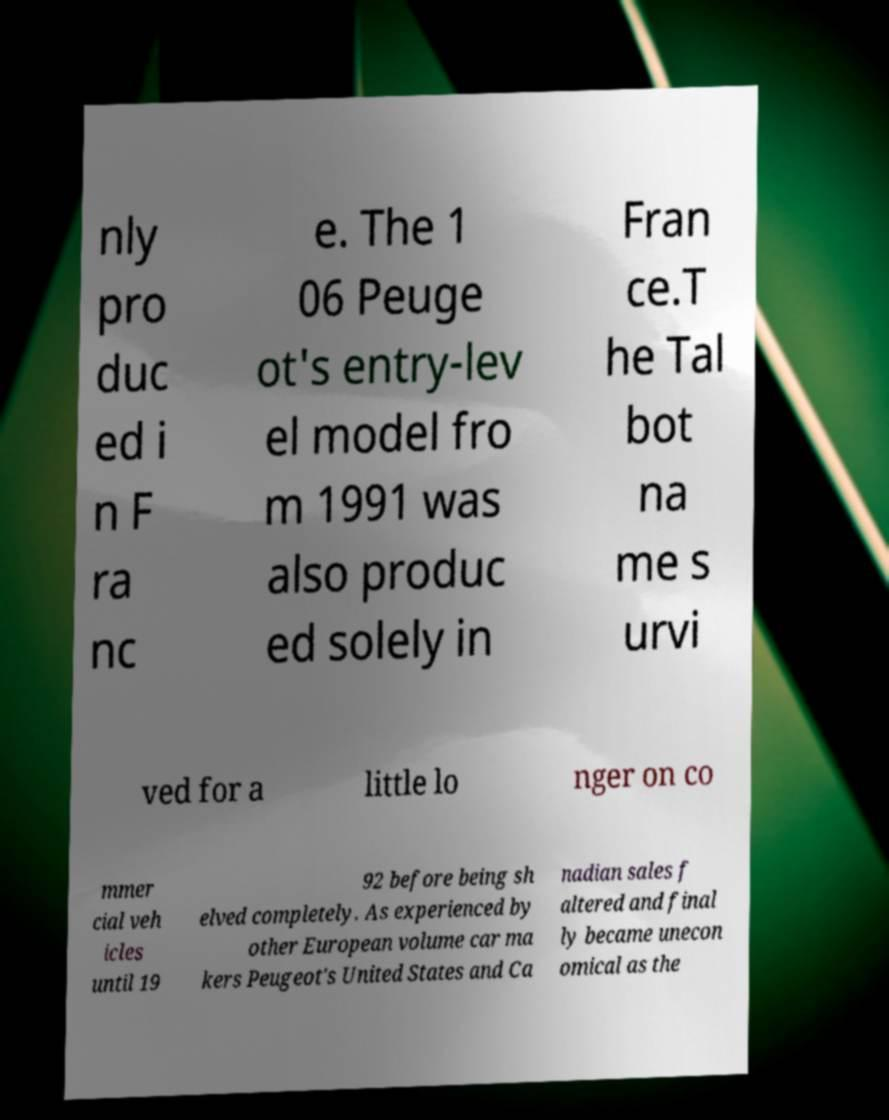Can you read and provide the text displayed in the image?This photo seems to have some interesting text. Can you extract and type it out for me? nly pro duc ed i n F ra nc e. The 1 06 Peuge ot's entry-lev el model fro m 1991 was also produc ed solely in Fran ce.T he Tal bot na me s urvi ved for a little lo nger on co mmer cial veh icles until 19 92 before being sh elved completely. As experienced by other European volume car ma kers Peugeot's United States and Ca nadian sales f altered and final ly became unecon omical as the 